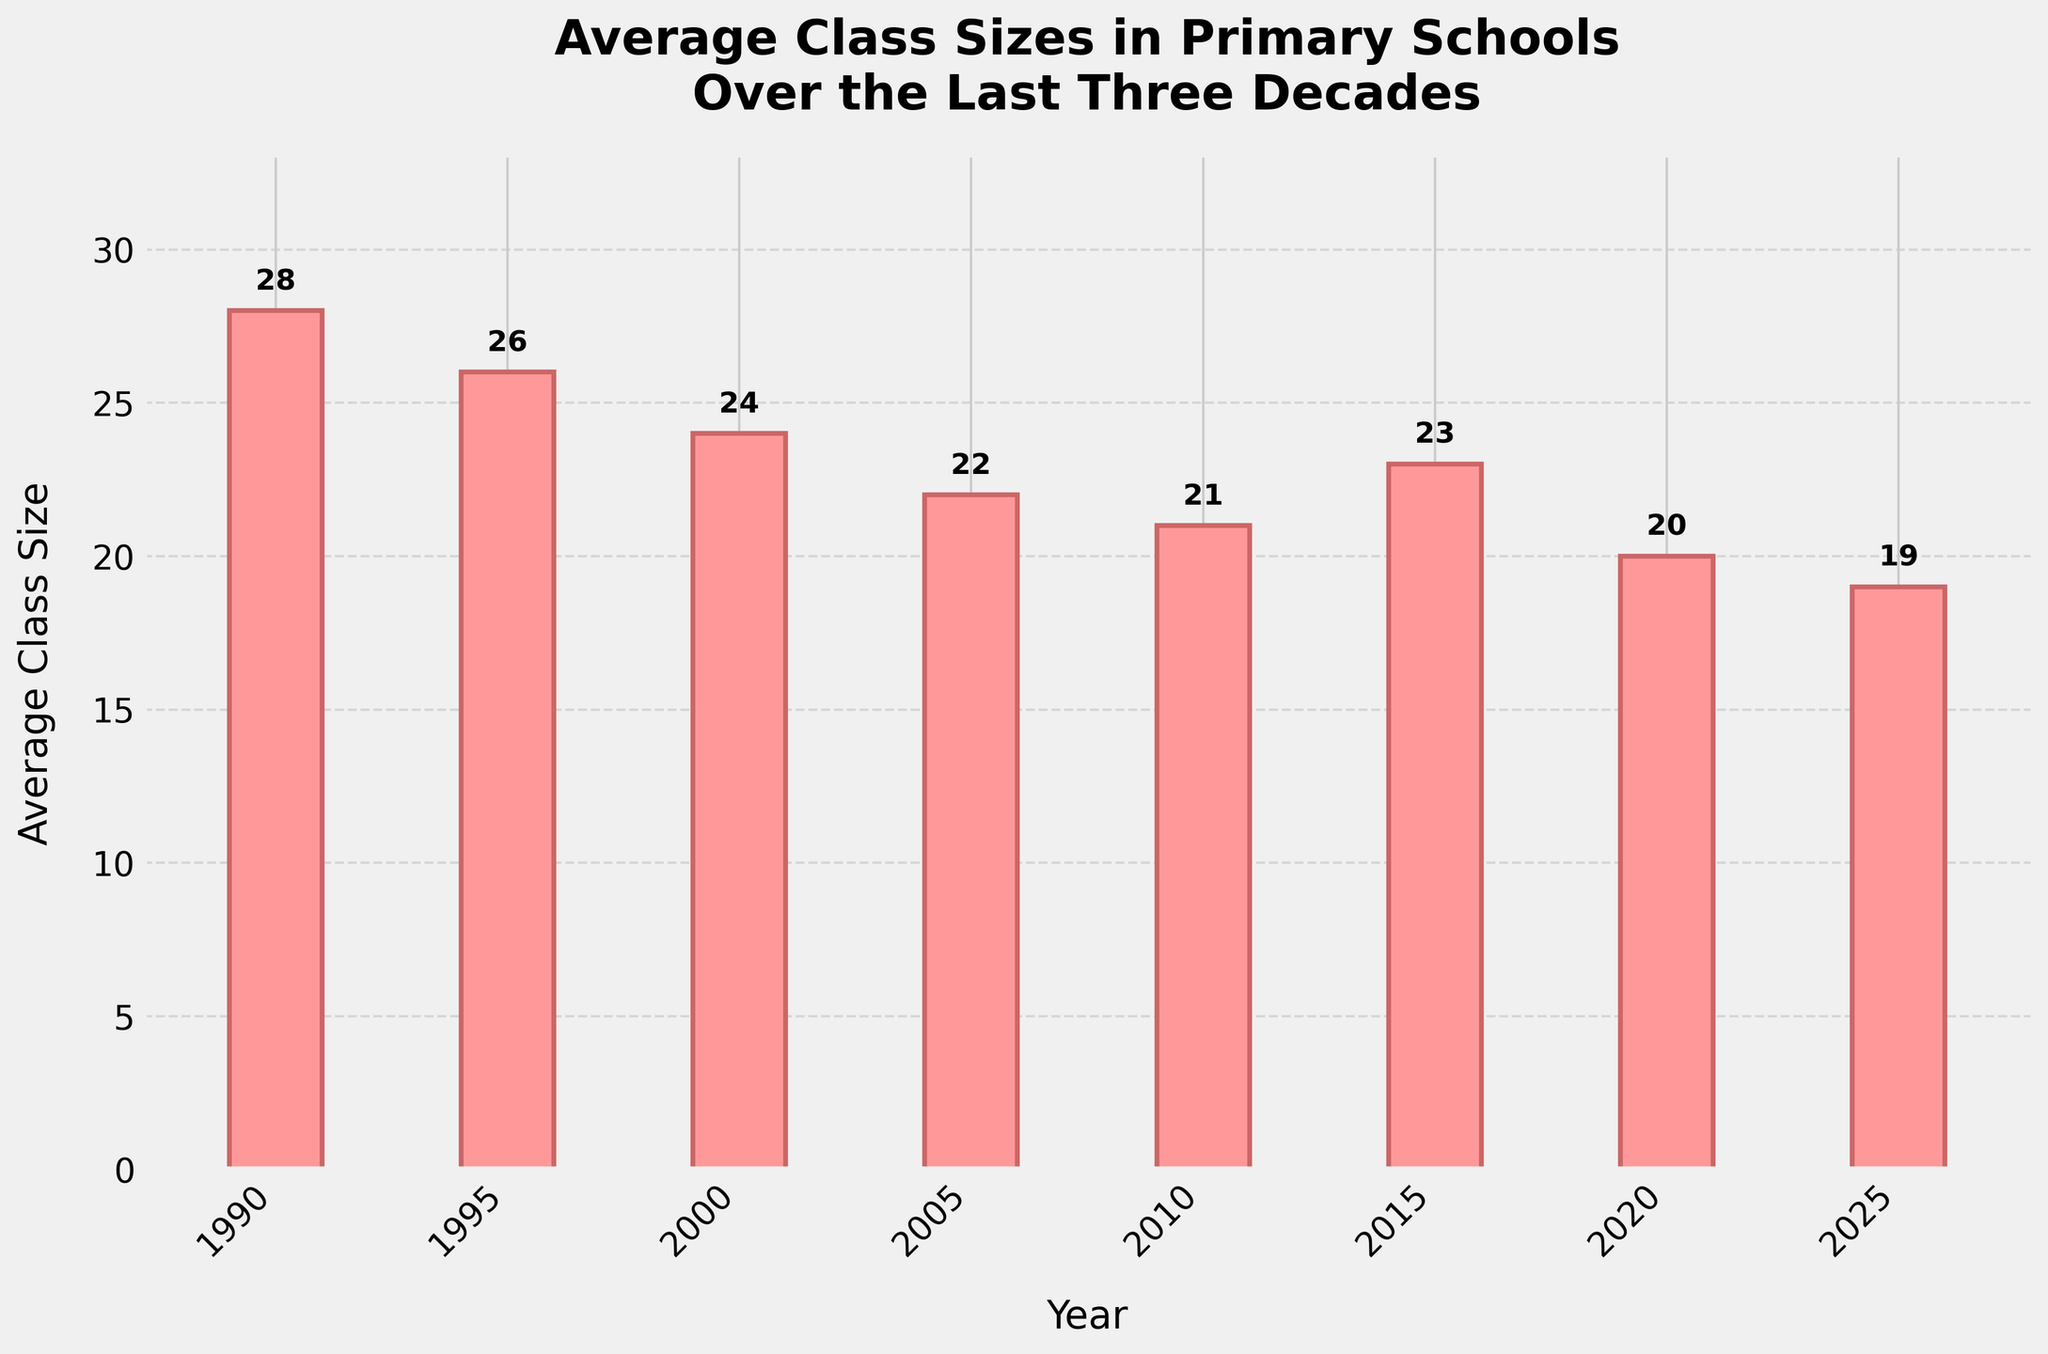What is the average class size in 1990? The bar representing the year 1990 shows an average class size, directly observable from the figure.
Answer: 28 How does the average class size in 2000 compare to that in 2020? The bar for 2000 shows an average class size of 24, and the bar for 2020 shows an average class size of 20.
Answer: The average class size in 2000 is 4 units higher than in 2020 What is the trend in average class sizes from 1990 to 2025? Observing the bars from 1990 to 2025, the average class size generally decreases over time with a few fluctuations.
Answer: The trend is generally decreasing In which year did the average class size increase compared to the previous year? Comparing the heights of consecutive bars, from 2010 to 2015, the bar height increases from 21 to 23.
Answer: 2015 What is the difference between the highest and lowest average class sizes shown? The highest average class size is 28 (1990), and the lowest is 19 (2025). The difference is 28 - 19.
Answer: 9 Which years have an average class size equal to or lower than 22? Bars that are at or below the height corresponding to an average class size of 22 include 2005 (22), 2010 (21), 2020 (20), and 2025 (19).
Answer: 2005, 2010, 2020, 2025 What is the average class size in 2015, and how much has it changed by 2025? The average class size in 2015 is 23. By 2025, it decreased to 19. The change is 23 - 19.
Answer: It decreased by 4 Which year had the largest average class size, and what was it? The tallest bar indicates the largest average class size, which is in 1990 with a value of 28.
Answer: 1990, 28 How many years show an average class size below 25? Observing the bars, the years with an average class size below 25 are 2000 (24), 2005 (22), 2010 (21), 2015 (23), 2020 (20), and 2025 (19).
Answer: 6 